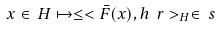<formula> <loc_0><loc_0><loc_500><loc_500>x \in \, H \mapsto \leq < \bar { F } ( x ) , h \ r > _ { H } \in \, \real s</formula> 